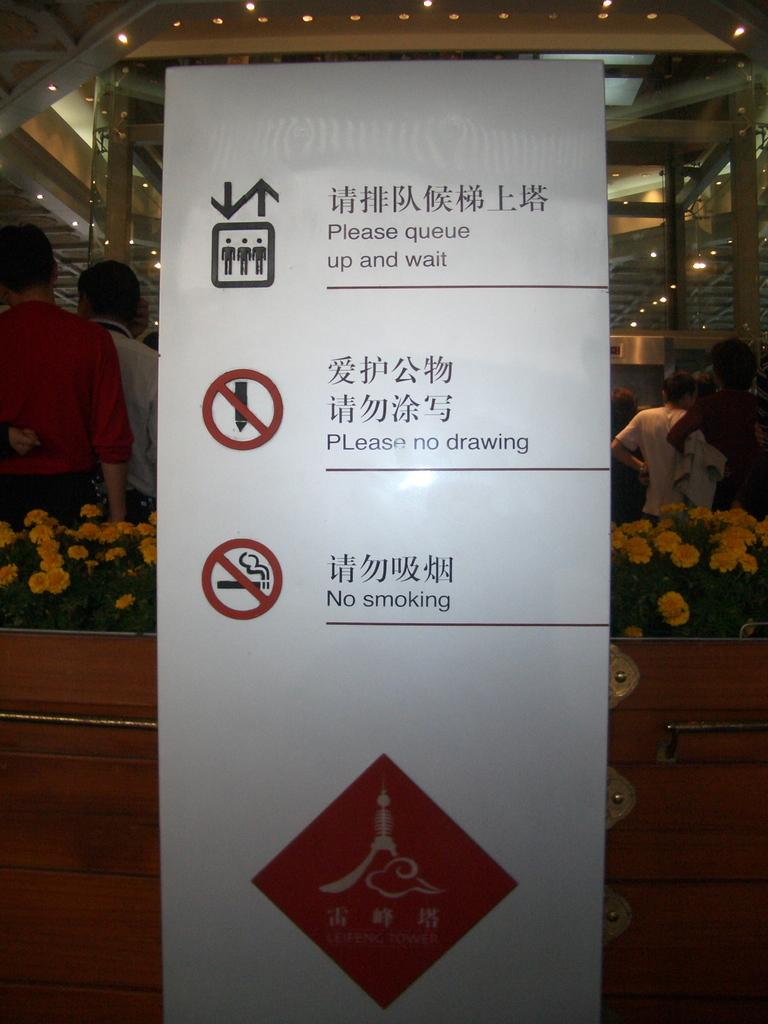What is the main object in the image? There is a board in the image. What can be seen behind the board? Flowers, plants, people, and lights are visible behind the board. Can you describe the background of the image? The background of the image includes a variety of elements, such as flowers, plants, people, and lights. How many girls are sitting on the machine in the image? There are no girls or machines present in the image. 